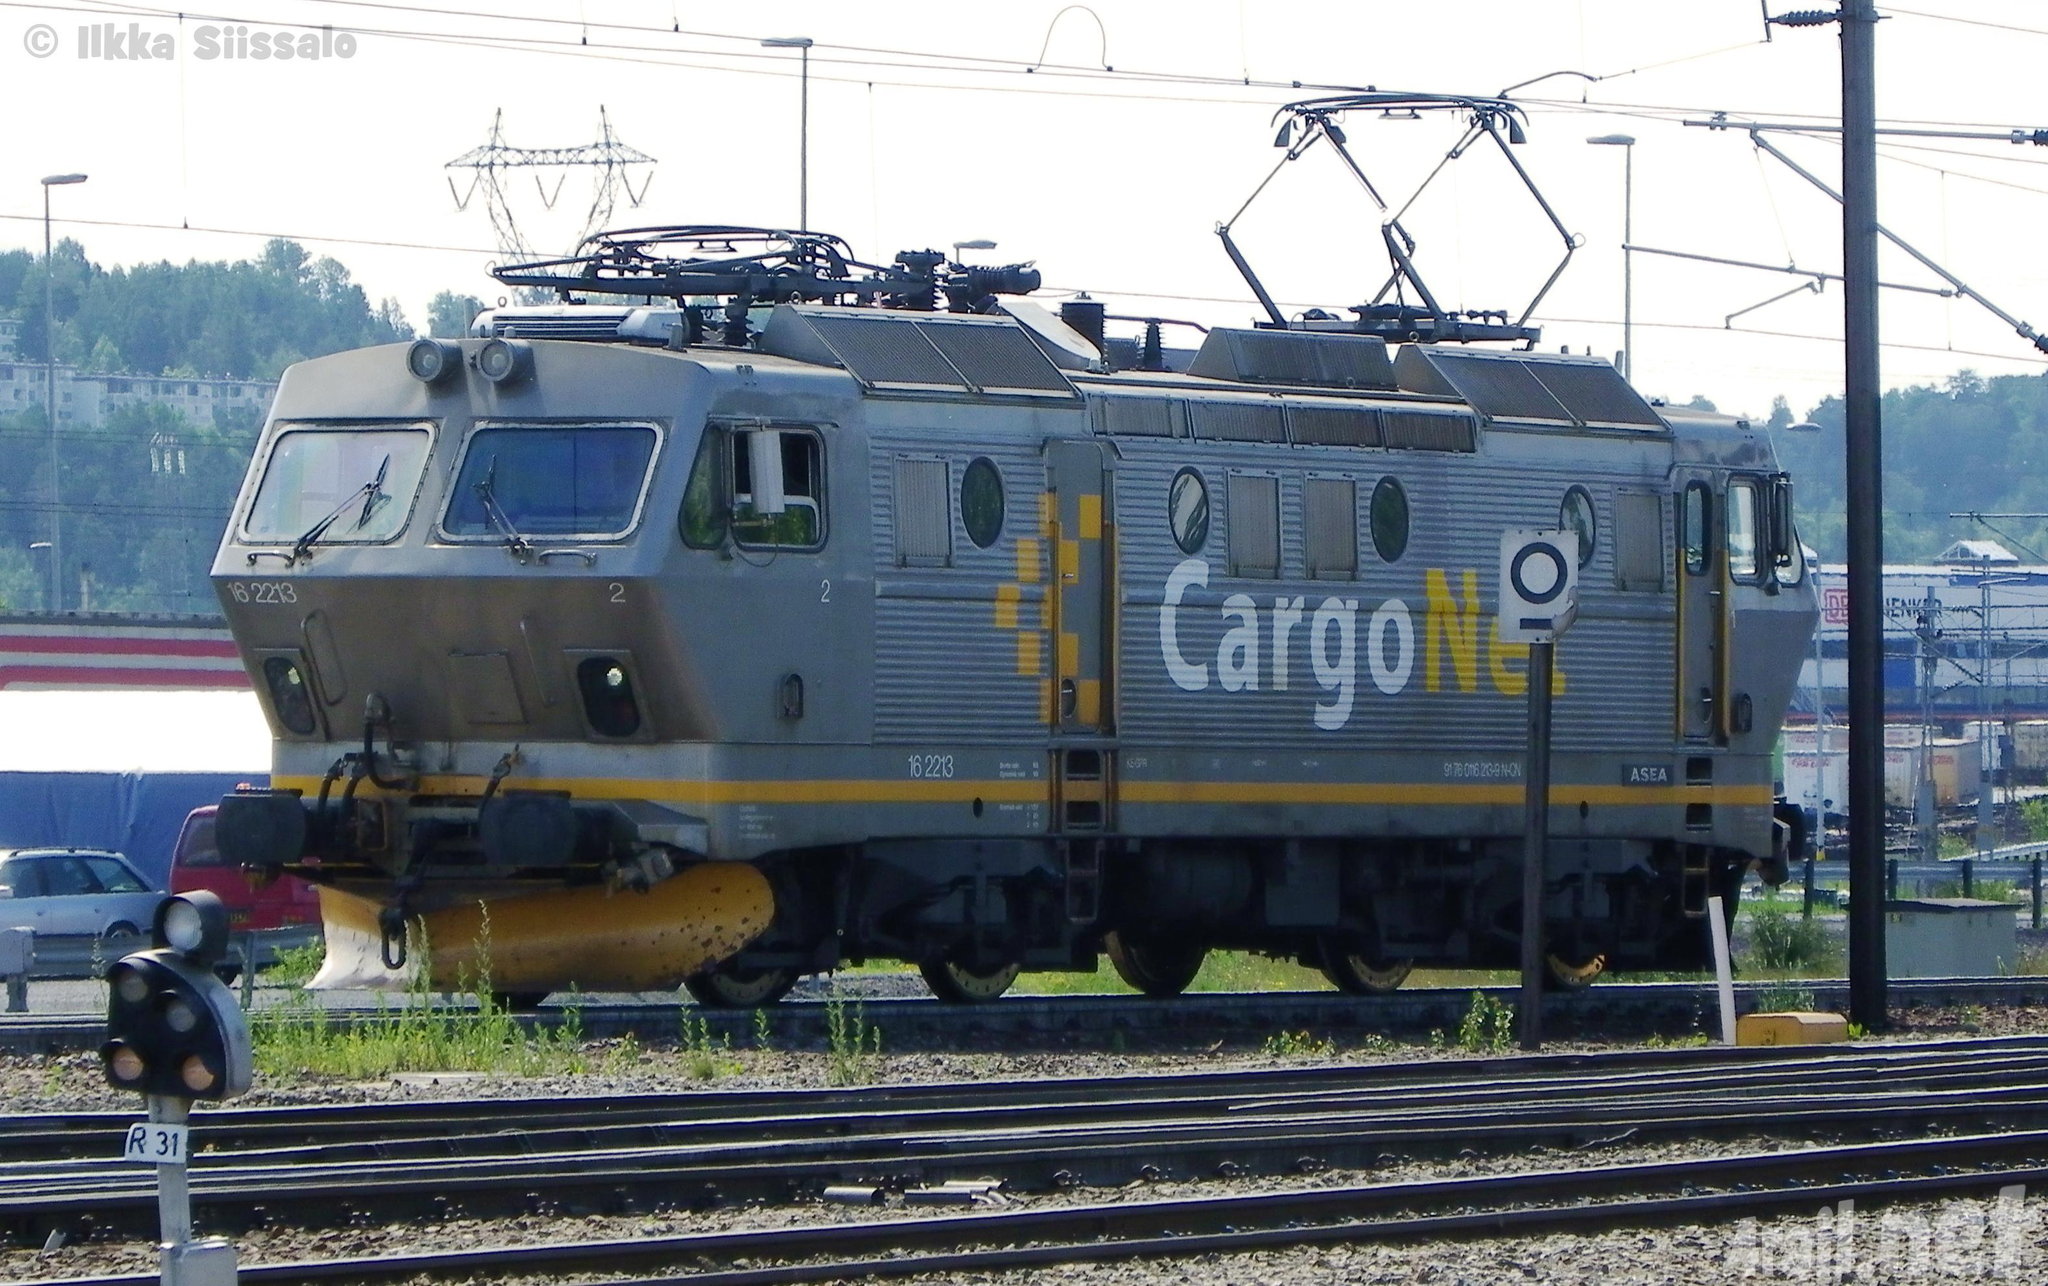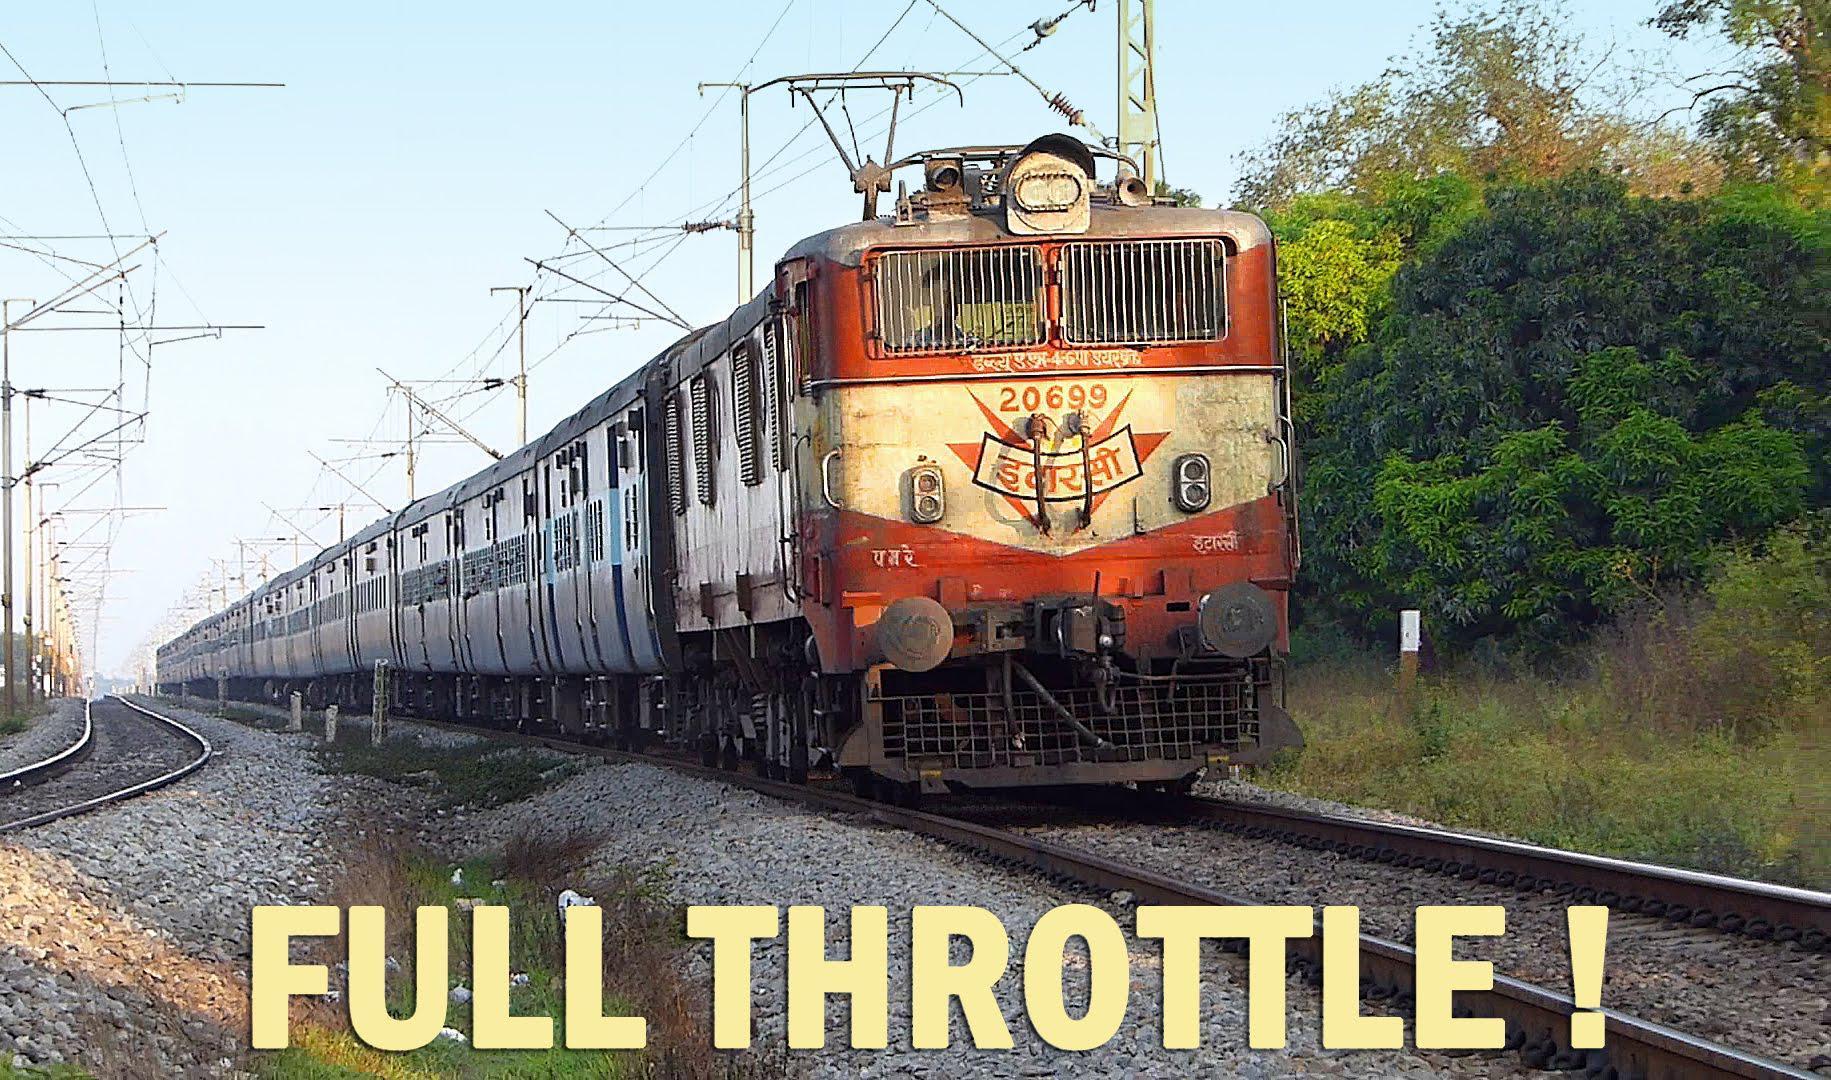The first image is the image on the left, the second image is the image on the right. Considering the images on both sides, is "There are three red stripes on the front of the train in the image on the left." valid? Answer yes or no. No. 